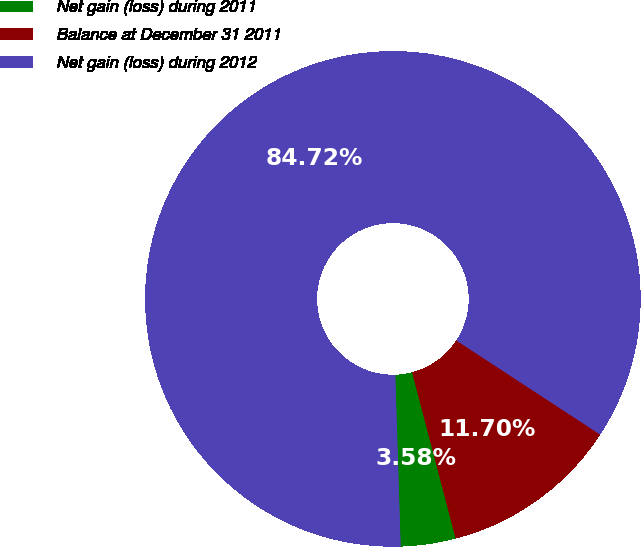Convert chart to OTSL. <chart><loc_0><loc_0><loc_500><loc_500><pie_chart><fcel>Net gain (loss) during 2011<fcel>Balance at December 31 2011<fcel>Net gain (loss) during 2012<nl><fcel>3.58%<fcel>11.7%<fcel>84.72%<nl></chart> 